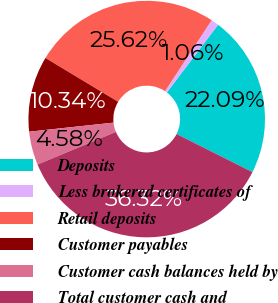Convert chart. <chart><loc_0><loc_0><loc_500><loc_500><pie_chart><fcel>Deposits<fcel>Less brokered certificates of<fcel>Retail deposits<fcel>Customer payables<fcel>Customer cash balances held by<fcel>Total customer cash and<nl><fcel>22.09%<fcel>1.06%<fcel>25.62%<fcel>10.34%<fcel>4.58%<fcel>36.32%<nl></chart> 